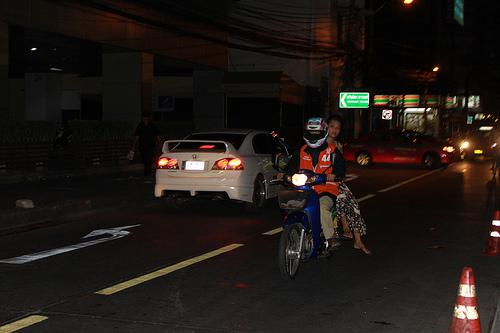Question: where are yellow lines?
Choices:
A. On the street.
B. On the curb.
C. On the sidewalk.
D. On the grass.
Answer with the letter. Answer: A Question: who is riding a motorbike?
Choices:
A. One person.
B. Two people.
C. One person with a dog.
D. One person with a cat.
Answer with the letter. Answer: B Question: where was the photo taken?
Choices:
A. On a city street.
B. On a rural road.
C. On a hiking trail.
D. On a train track.
Answer with the letter. Answer: A Question: when was the picture taken?
Choices:
A. Sunrise.
B. Sunset.
C. Night.
D. Daytime.
Answer with the letter. Answer: C Question: what is orange and white?
Choices:
A. Signs.
B. Uniforms.
C. Cones.
D. Buildings.
Answer with the letter. Answer: C Question: what is lit red?
Choices:
A. Traffic light.
B. Flashlights.
C. Car's rear lights.
D. Street lights.
Answer with the letter. Answer: C 